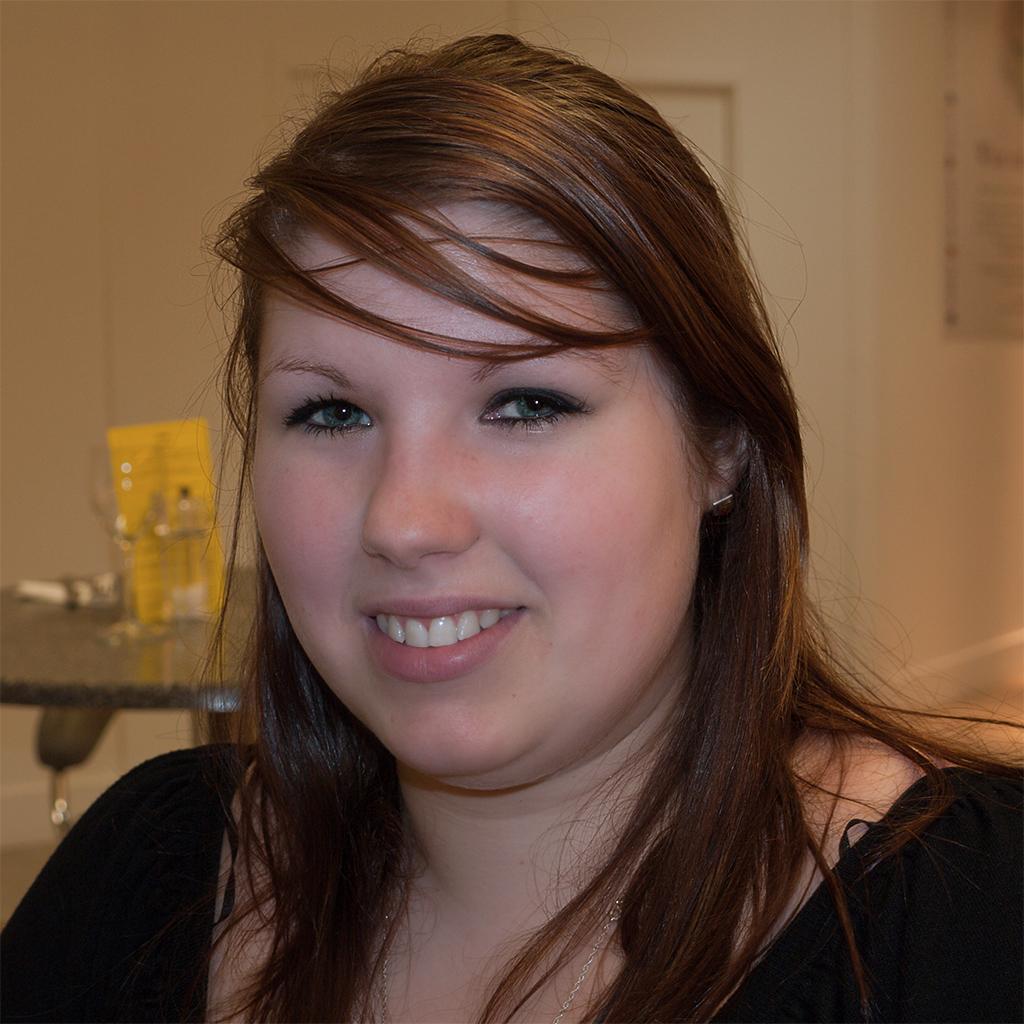How would you summarize this image in a sentence or two? In this image I can see a woman wearing black color dress is smiling. In the background I can see a table with few objects on it, a cream colored wall and the door. 